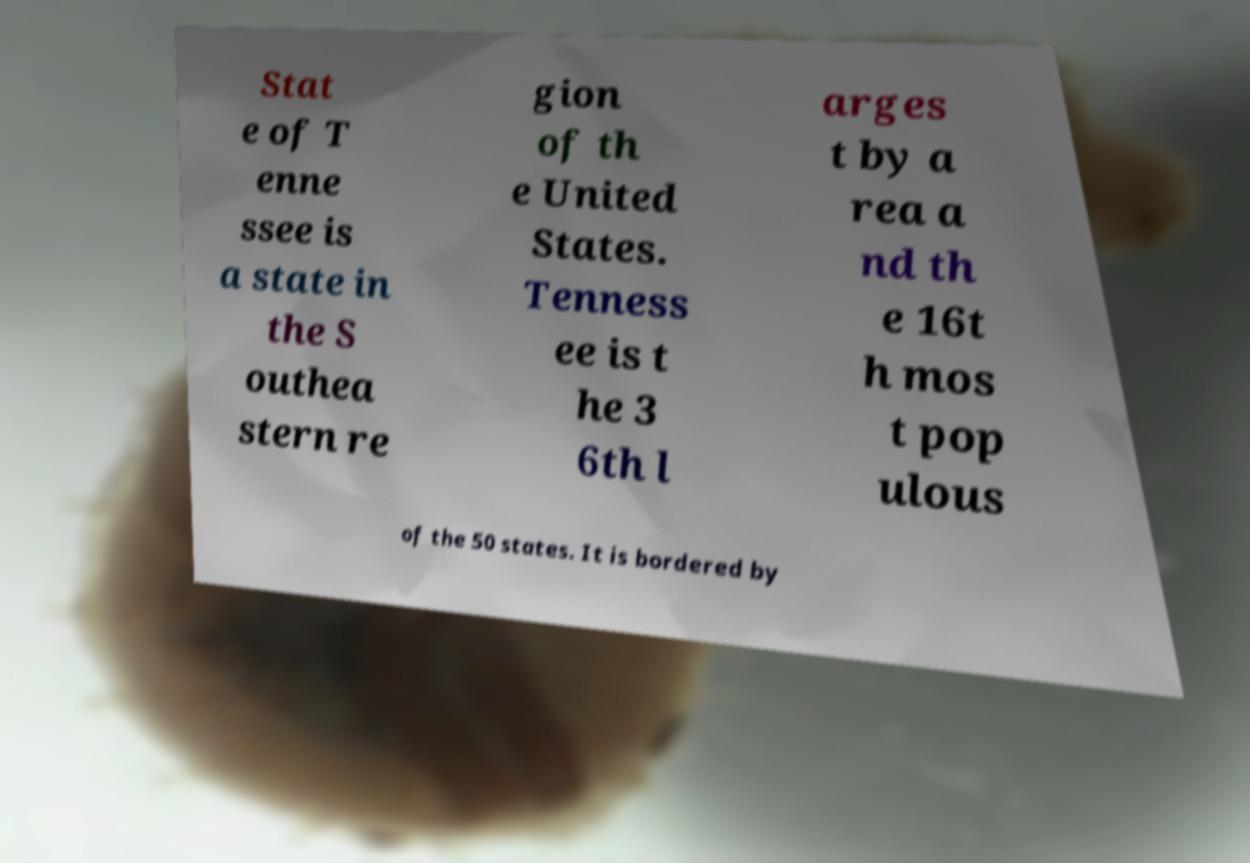Can you accurately transcribe the text from the provided image for me? Stat e of T enne ssee is a state in the S outhea stern re gion of th e United States. Tenness ee is t he 3 6th l arges t by a rea a nd th e 16t h mos t pop ulous of the 50 states. It is bordered by 